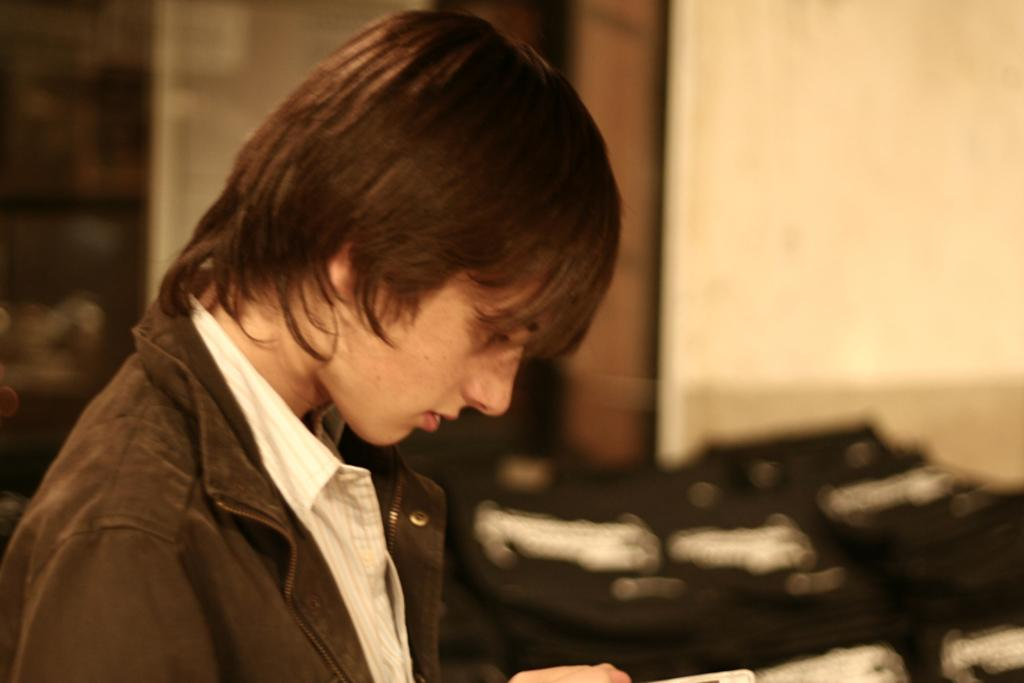Who is present in the image? There is a man in the image. What can be observed about the background of the image? The background of the image is blurry. What type of structure is visible in the background? There is a wall in the background of the image. What else can be seen in the background of the image? There are objects in the background of the image. What type of snake is crawling out of the man's mouth in the image? There is no snake present in the image, nor is there any indication of a snake coming out of the man's mouth. 